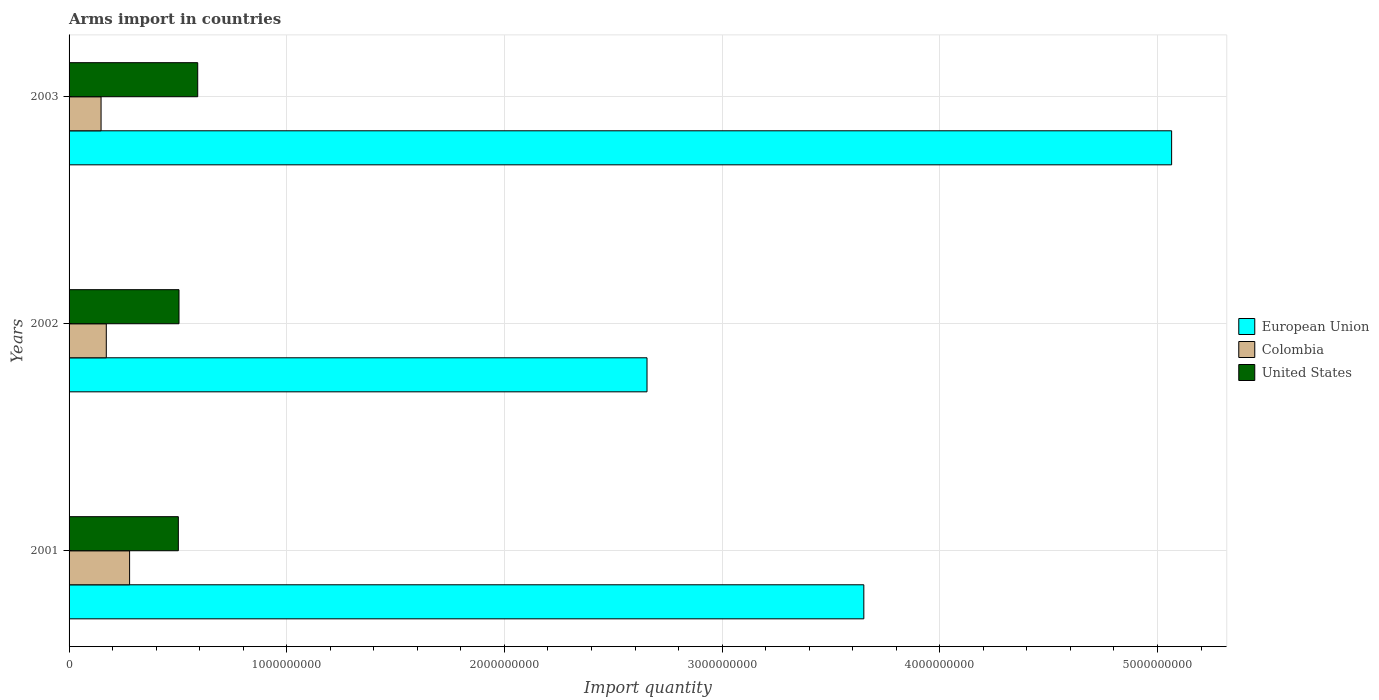How many different coloured bars are there?
Give a very brief answer. 3. How many bars are there on the 1st tick from the top?
Your response must be concise. 3. What is the label of the 2nd group of bars from the top?
Provide a short and direct response. 2002. In how many cases, is the number of bars for a given year not equal to the number of legend labels?
Offer a very short reply. 0. What is the total arms import in European Union in 2003?
Keep it short and to the point. 5.06e+09. Across all years, what is the maximum total arms import in Colombia?
Your answer should be compact. 2.78e+08. Across all years, what is the minimum total arms import in Colombia?
Provide a succinct answer. 1.47e+08. What is the total total arms import in European Union in the graph?
Your answer should be compact. 1.14e+1. What is the difference between the total arms import in United States in 2001 and that in 2003?
Your answer should be compact. -8.90e+07. What is the difference between the total arms import in European Union in 2003 and the total arms import in Colombia in 2002?
Give a very brief answer. 4.89e+09. What is the average total arms import in United States per year?
Offer a very short reply. 5.33e+08. In the year 2001, what is the difference between the total arms import in European Union and total arms import in United States?
Make the answer very short. 3.15e+09. In how many years, is the total arms import in United States greater than 2600000000 ?
Offer a terse response. 0. What is the ratio of the total arms import in United States in 2001 to that in 2002?
Give a very brief answer. 0.99. Is the total arms import in European Union in 2001 less than that in 2003?
Your response must be concise. Yes. Is the difference between the total arms import in European Union in 2001 and 2003 greater than the difference between the total arms import in United States in 2001 and 2003?
Offer a terse response. No. What is the difference between the highest and the second highest total arms import in European Union?
Your answer should be very brief. 1.41e+09. What is the difference between the highest and the lowest total arms import in United States?
Ensure brevity in your answer.  8.90e+07. In how many years, is the total arms import in European Union greater than the average total arms import in European Union taken over all years?
Provide a short and direct response. 1. Is the sum of the total arms import in Colombia in 2001 and 2002 greater than the maximum total arms import in European Union across all years?
Your answer should be very brief. No. What does the 1st bar from the top in 2003 represents?
Provide a succinct answer. United States. Is it the case that in every year, the sum of the total arms import in Colombia and total arms import in United States is greater than the total arms import in European Union?
Give a very brief answer. No. How many bars are there?
Give a very brief answer. 9. Are all the bars in the graph horizontal?
Your response must be concise. Yes. How many years are there in the graph?
Offer a very short reply. 3. What is the difference between two consecutive major ticks on the X-axis?
Provide a short and direct response. 1.00e+09. Does the graph contain any zero values?
Provide a succinct answer. No. How many legend labels are there?
Your answer should be very brief. 3. How are the legend labels stacked?
Offer a terse response. Vertical. What is the title of the graph?
Provide a short and direct response. Arms import in countries. Does "Cameroon" appear as one of the legend labels in the graph?
Offer a terse response. No. What is the label or title of the X-axis?
Keep it short and to the point. Import quantity. What is the label or title of the Y-axis?
Provide a succinct answer. Years. What is the Import quantity in European Union in 2001?
Provide a short and direct response. 3.65e+09. What is the Import quantity of Colombia in 2001?
Your answer should be very brief. 2.78e+08. What is the Import quantity of United States in 2001?
Your answer should be compact. 5.02e+08. What is the Import quantity of European Union in 2002?
Provide a succinct answer. 2.66e+09. What is the Import quantity of Colombia in 2002?
Provide a succinct answer. 1.71e+08. What is the Import quantity of United States in 2002?
Offer a terse response. 5.05e+08. What is the Import quantity of European Union in 2003?
Ensure brevity in your answer.  5.06e+09. What is the Import quantity in Colombia in 2003?
Offer a terse response. 1.47e+08. What is the Import quantity of United States in 2003?
Your response must be concise. 5.91e+08. Across all years, what is the maximum Import quantity in European Union?
Your answer should be compact. 5.06e+09. Across all years, what is the maximum Import quantity of Colombia?
Provide a succinct answer. 2.78e+08. Across all years, what is the maximum Import quantity of United States?
Keep it short and to the point. 5.91e+08. Across all years, what is the minimum Import quantity of European Union?
Your response must be concise. 2.66e+09. Across all years, what is the minimum Import quantity in Colombia?
Offer a very short reply. 1.47e+08. Across all years, what is the minimum Import quantity in United States?
Keep it short and to the point. 5.02e+08. What is the total Import quantity of European Union in the graph?
Give a very brief answer. 1.14e+1. What is the total Import quantity of Colombia in the graph?
Offer a terse response. 5.96e+08. What is the total Import quantity of United States in the graph?
Offer a very short reply. 1.60e+09. What is the difference between the Import quantity in European Union in 2001 and that in 2002?
Your answer should be very brief. 9.96e+08. What is the difference between the Import quantity in Colombia in 2001 and that in 2002?
Give a very brief answer. 1.07e+08. What is the difference between the Import quantity of United States in 2001 and that in 2002?
Offer a very short reply. -3.00e+06. What is the difference between the Import quantity of European Union in 2001 and that in 2003?
Keep it short and to the point. -1.41e+09. What is the difference between the Import quantity of Colombia in 2001 and that in 2003?
Make the answer very short. 1.31e+08. What is the difference between the Import quantity in United States in 2001 and that in 2003?
Your answer should be very brief. -8.90e+07. What is the difference between the Import quantity in European Union in 2002 and that in 2003?
Your answer should be compact. -2.41e+09. What is the difference between the Import quantity in Colombia in 2002 and that in 2003?
Your answer should be compact. 2.40e+07. What is the difference between the Import quantity of United States in 2002 and that in 2003?
Make the answer very short. -8.60e+07. What is the difference between the Import quantity in European Union in 2001 and the Import quantity in Colombia in 2002?
Provide a short and direct response. 3.48e+09. What is the difference between the Import quantity in European Union in 2001 and the Import quantity in United States in 2002?
Keep it short and to the point. 3.15e+09. What is the difference between the Import quantity in Colombia in 2001 and the Import quantity in United States in 2002?
Your answer should be compact. -2.27e+08. What is the difference between the Import quantity of European Union in 2001 and the Import quantity of Colombia in 2003?
Make the answer very short. 3.50e+09. What is the difference between the Import quantity of European Union in 2001 and the Import quantity of United States in 2003?
Keep it short and to the point. 3.06e+09. What is the difference between the Import quantity of Colombia in 2001 and the Import quantity of United States in 2003?
Make the answer very short. -3.13e+08. What is the difference between the Import quantity of European Union in 2002 and the Import quantity of Colombia in 2003?
Provide a short and direct response. 2.51e+09. What is the difference between the Import quantity of European Union in 2002 and the Import quantity of United States in 2003?
Keep it short and to the point. 2.06e+09. What is the difference between the Import quantity of Colombia in 2002 and the Import quantity of United States in 2003?
Your response must be concise. -4.20e+08. What is the average Import quantity of European Union per year?
Keep it short and to the point. 3.79e+09. What is the average Import quantity of Colombia per year?
Offer a terse response. 1.99e+08. What is the average Import quantity in United States per year?
Your answer should be compact. 5.33e+08. In the year 2001, what is the difference between the Import quantity in European Union and Import quantity in Colombia?
Offer a terse response. 3.37e+09. In the year 2001, what is the difference between the Import quantity in European Union and Import quantity in United States?
Your answer should be compact. 3.15e+09. In the year 2001, what is the difference between the Import quantity in Colombia and Import quantity in United States?
Offer a terse response. -2.24e+08. In the year 2002, what is the difference between the Import quantity of European Union and Import quantity of Colombia?
Your answer should be very brief. 2.48e+09. In the year 2002, what is the difference between the Import quantity of European Union and Import quantity of United States?
Give a very brief answer. 2.15e+09. In the year 2002, what is the difference between the Import quantity in Colombia and Import quantity in United States?
Provide a short and direct response. -3.34e+08. In the year 2003, what is the difference between the Import quantity in European Union and Import quantity in Colombia?
Keep it short and to the point. 4.92e+09. In the year 2003, what is the difference between the Import quantity in European Union and Import quantity in United States?
Offer a terse response. 4.47e+09. In the year 2003, what is the difference between the Import quantity in Colombia and Import quantity in United States?
Offer a very short reply. -4.44e+08. What is the ratio of the Import quantity of European Union in 2001 to that in 2002?
Your answer should be compact. 1.38. What is the ratio of the Import quantity in Colombia in 2001 to that in 2002?
Keep it short and to the point. 1.63. What is the ratio of the Import quantity in United States in 2001 to that in 2002?
Keep it short and to the point. 0.99. What is the ratio of the Import quantity of European Union in 2001 to that in 2003?
Your answer should be compact. 0.72. What is the ratio of the Import quantity of Colombia in 2001 to that in 2003?
Provide a short and direct response. 1.89. What is the ratio of the Import quantity of United States in 2001 to that in 2003?
Provide a short and direct response. 0.85. What is the ratio of the Import quantity in European Union in 2002 to that in 2003?
Ensure brevity in your answer.  0.52. What is the ratio of the Import quantity of Colombia in 2002 to that in 2003?
Offer a very short reply. 1.16. What is the ratio of the Import quantity in United States in 2002 to that in 2003?
Your answer should be compact. 0.85. What is the difference between the highest and the second highest Import quantity of European Union?
Provide a short and direct response. 1.41e+09. What is the difference between the highest and the second highest Import quantity in Colombia?
Offer a terse response. 1.07e+08. What is the difference between the highest and the second highest Import quantity in United States?
Your response must be concise. 8.60e+07. What is the difference between the highest and the lowest Import quantity in European Union?
Your response must be concise. 2.41e+09. What is the difference between the highest and the lowest Import quantity of Colombia?
Keep it short and to the point. 1.31e+08. What is the difference between the highest and the lowest Import quantity of United States?
Your response must be concise. 8.90e+07. 